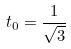Convert formula to latex. <formula><loc_0><loc_0><loc_500><loc_500>t _ { 0 } = \frac { 1 } { \sqrt { 3 } }</formula> 